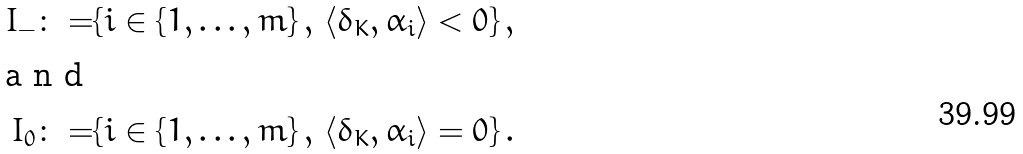<formula> <loc_0><loc_0><loc_500><loc_500>I _ { - } \colon = & \{ i \in \{ 1 , \dots , m \} \, , \, \langle \delta _ { K } , \alpha _ { i } \rangle < 0 \} \, , \intertext { a n d } I _ { 0 } \colon = & \{ i \in \{ 1 , \dots , m \} \, , \, \langle \delta _ { K } , \alpha _ { i } \rangle = 0 \} \, .</formula> 